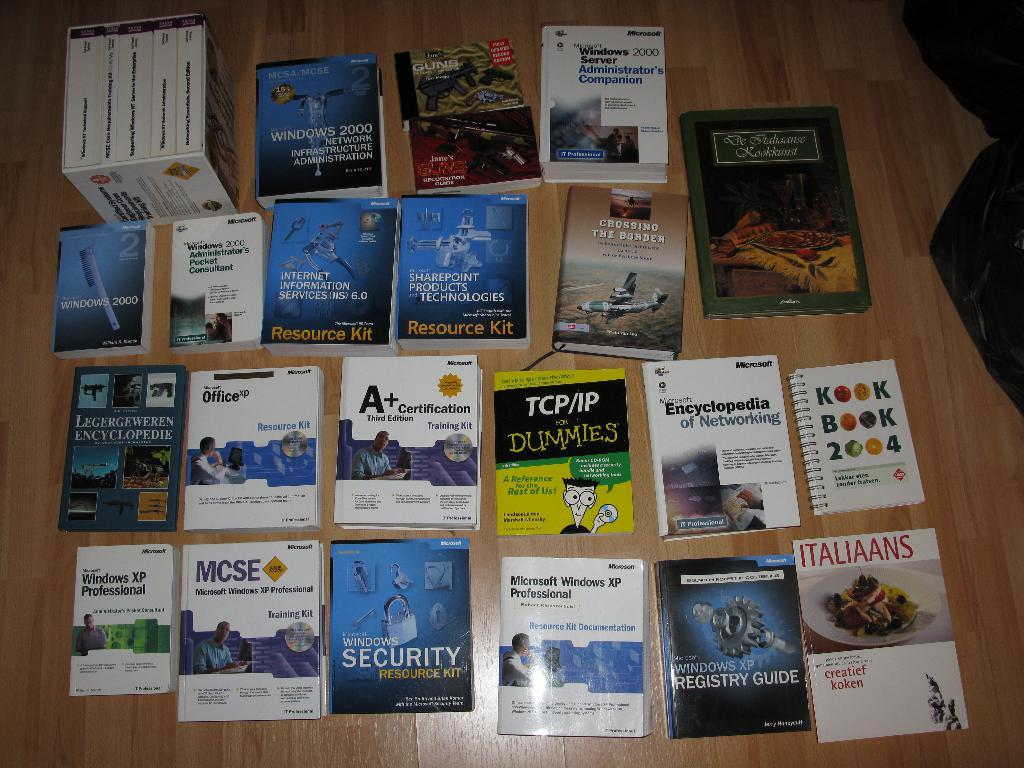<image>
Share a concise interpretation of the image provided. An assortment of books including a Windows security resource kit 